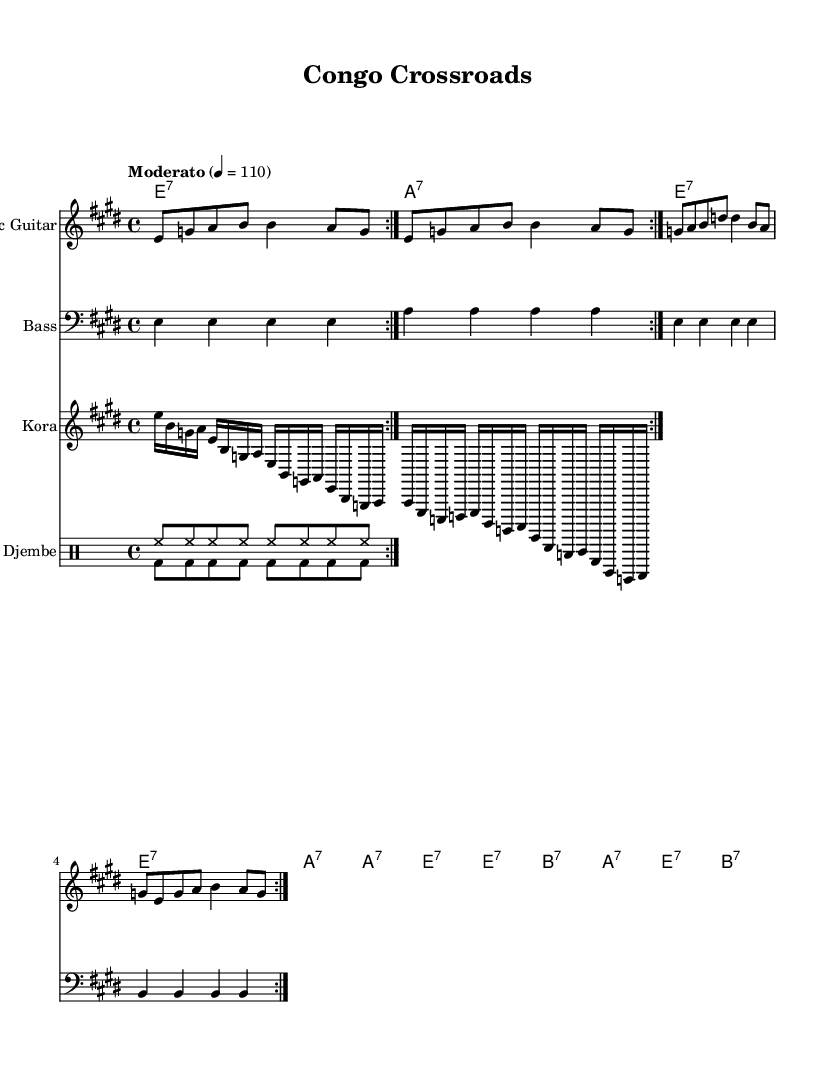What is the key signature of this music? The key signature is E major, which has four sharps (F#, C#, G#, and D#). This can be determined by looking at the initial part of the sheet music where the key signature is indicated.
Answer: E major What is the time signature of this music? The time signature is 4/4, which means there are four beats in each measure and the quarter note gets one beat. This is specified explicitly in the sheet music after the key signature.
Answer: 4/4 What is the tempo marking of this piece? The tempo is marked as "Moderato" with a metronome marking of quarter note equals 110. This is indicated at the beginning of the score, below the title section.
Answer: Moderato, 110 How many measures are repeated in the electric guitar part? The electric guitar part has a 2-measure repeat indicated by the "repeat volta 2" marking. This notation is present at the beginning of the electric guitar section, showing that the two measures will be played twice.
Answer: 2 measures Which instruments are included in this composition? The composition includes electric guitar, bass, kora, and djembe. Each instrument has its own separate staff in the score, clearly labeled with instrument names.
Answer: Electric guitar, bass, kora, djembe What type of chord progression is primarily used in this piece? The chord progression follows a standard blues pattern, primarily utilizing seventh chords (E7, A7, B7). This is identifiable in the chord names indicated above the staff in the chord mode section, which reflects a typical structure for blues music.
Answer: Seventh chords 